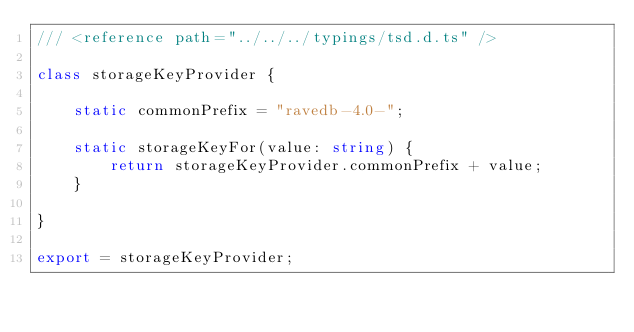Convert code to text. <code><loc_0><loc_0><loc_500><loc_500><_TypeScript_>/// <reference path="../../../typings/tsd.d.ts" />

class storageKeyProvider {

    static commonPrefix = "ravedb-4.0-";

    static storageKeyFor(value: string) {
        return storageKeyProvider.commonPrefix + value;
    }

}

export = storageKeyProvider;
</code> 